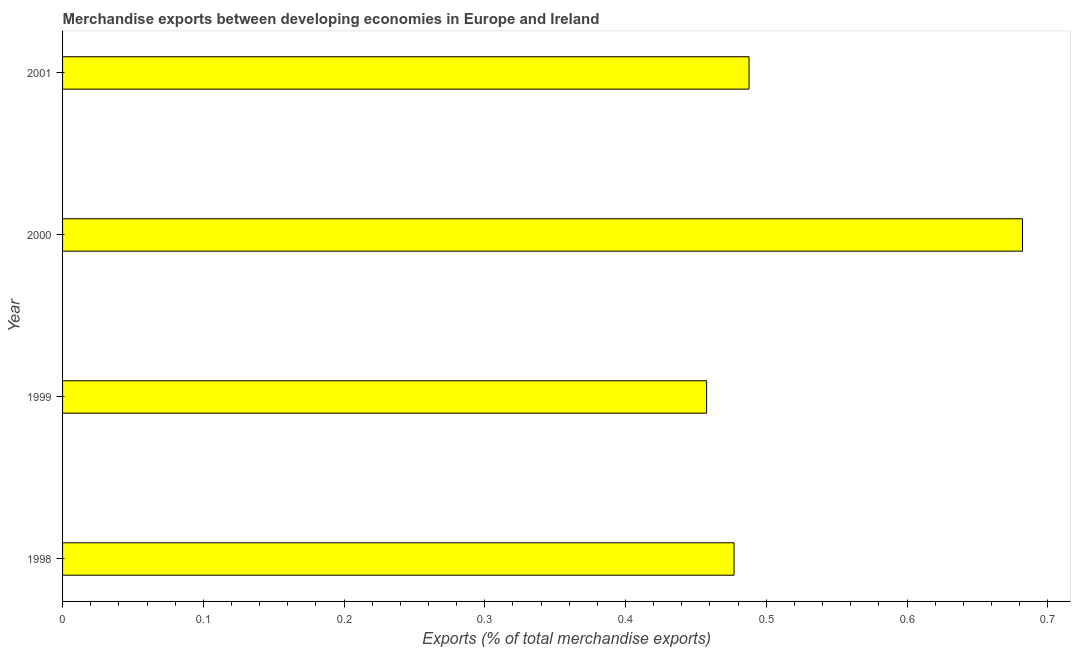Does the graph contain any zero values?
Your response must be concise. No. Does the graph contain grids?
Your answer should be compact. No. What is the title of the graph?
Offer a very short reply. Merchandise exports between developing economies in Europe and Ireland. What is the label or title of the X-axis?
Provide a succinct answer. Exports (% of total merchandise exports). What is the merchandise exports in 2001?
Your response must be concise. 0.49. Across all years, what is the maximum merchandise exports?
Your answer should be very brief. 0.68. Across all years, what is the minimum merchandise exports?
Offer a very short reply. 0.46. What is the sum of the merchandise exports?
Offer a terse response. 2.1. What is the difference between the merchandise exports in 1998 and 2000?
Your answer should be compact. -0.2. What is the average merchandise exports per year?
Ensure brevity in your answer.  0.53. What is the median merchandise exports?
Provide a short and direct response. 0.48. Do a majority of the years between 1999 and 2001 (inclusive) have merchandise exports greater than 0.22 %?
Your answer should be compact. Yes. What is the ratio of the merchandise exports in 1998 to that in 1999?
Make the answer very short. 1.04. What is the difference between the highest and the second highest merchandise exports?
Offer a very short reply. 0.19. Is the sum of the merchandise exports in 1999 and 2000 greater than the maximum merchandise exports across all years?
Your answer should be very brief. Yes. What is the difference between the highest and the lowest merchandise exports?
Provide a succinct answer. 0.22. In how many years, is the merchandise exports greater than the average merchandise exports taken over all years?
Keep it short and to the point. 1. How many bars are there?
Provide a short and direct response. 4. How many years are there in the graph?
Make the answer very short. 4. What is the difference between two consecutive major ticks on the X-axis?
Offer a very short reply. 0.1. Are the values on the major ticks of X-axis written in scientific E-notation?
Provide a succinct answer. No. What is the Exports (% of total merchandise exports) of 1998?
Offer a terse response. 0.48. What is the Exports (% of total merchandise exports) in 1999?
Keep it short and to the point. 0.46. What is the Exports (% of total merchandise exports) in 2000?
Offer a very short reply. 0.68. What is the Exports (% of total merchandise exports) of 2001?
Make the answer very short. 0.49. What is the difference between the Exports (% of total merchandise exports) in 1998 and 1999?
Make the answer very short. 0.02. What is the difference between the Exports (% of total merchandise exports) in 1998 and 2000?
Give a very brief answer. -0.2. What is the difference between the Exports (% of total merchandise exports) in 1998 and 2001?
Keep it short and to the point. -0.01. What is the difference between the Exports (% of total merchandise exports) in 1999 and 2000?
Offer a terse response. -0.22. What is the difference between the Exports (% of total merchandise exports) in 1999 and 2001?
Offer a terse response. -0.03. What is the difference between the Exports (% of total merchandise exports) in 2000 and 2001?
Ensure brevity in your answer.  0.19. What is the ratio of the Exports (% of total merchandise exports) in 1998 to that in 1999?
Provide a short and direct response. 1.04. What is the ratio of the Exports (% of total merchandise exports) in 1998 to that in 2000?
Keep it short and to the point. 0.7. What is the ratio of the Exports (% of total merchandise exports) in 1999 to that in 2000?
Offer a terse response. 0.67. What is the ratio of the Exports (% of total merchandise exports) in 1999 to that in 2001?
Offer a terse response. 0.94. What is the ratio of the Exports (% of total merchandise exports) in 2000 to that in 2001?
Provide a short and direct response. 1.4. 